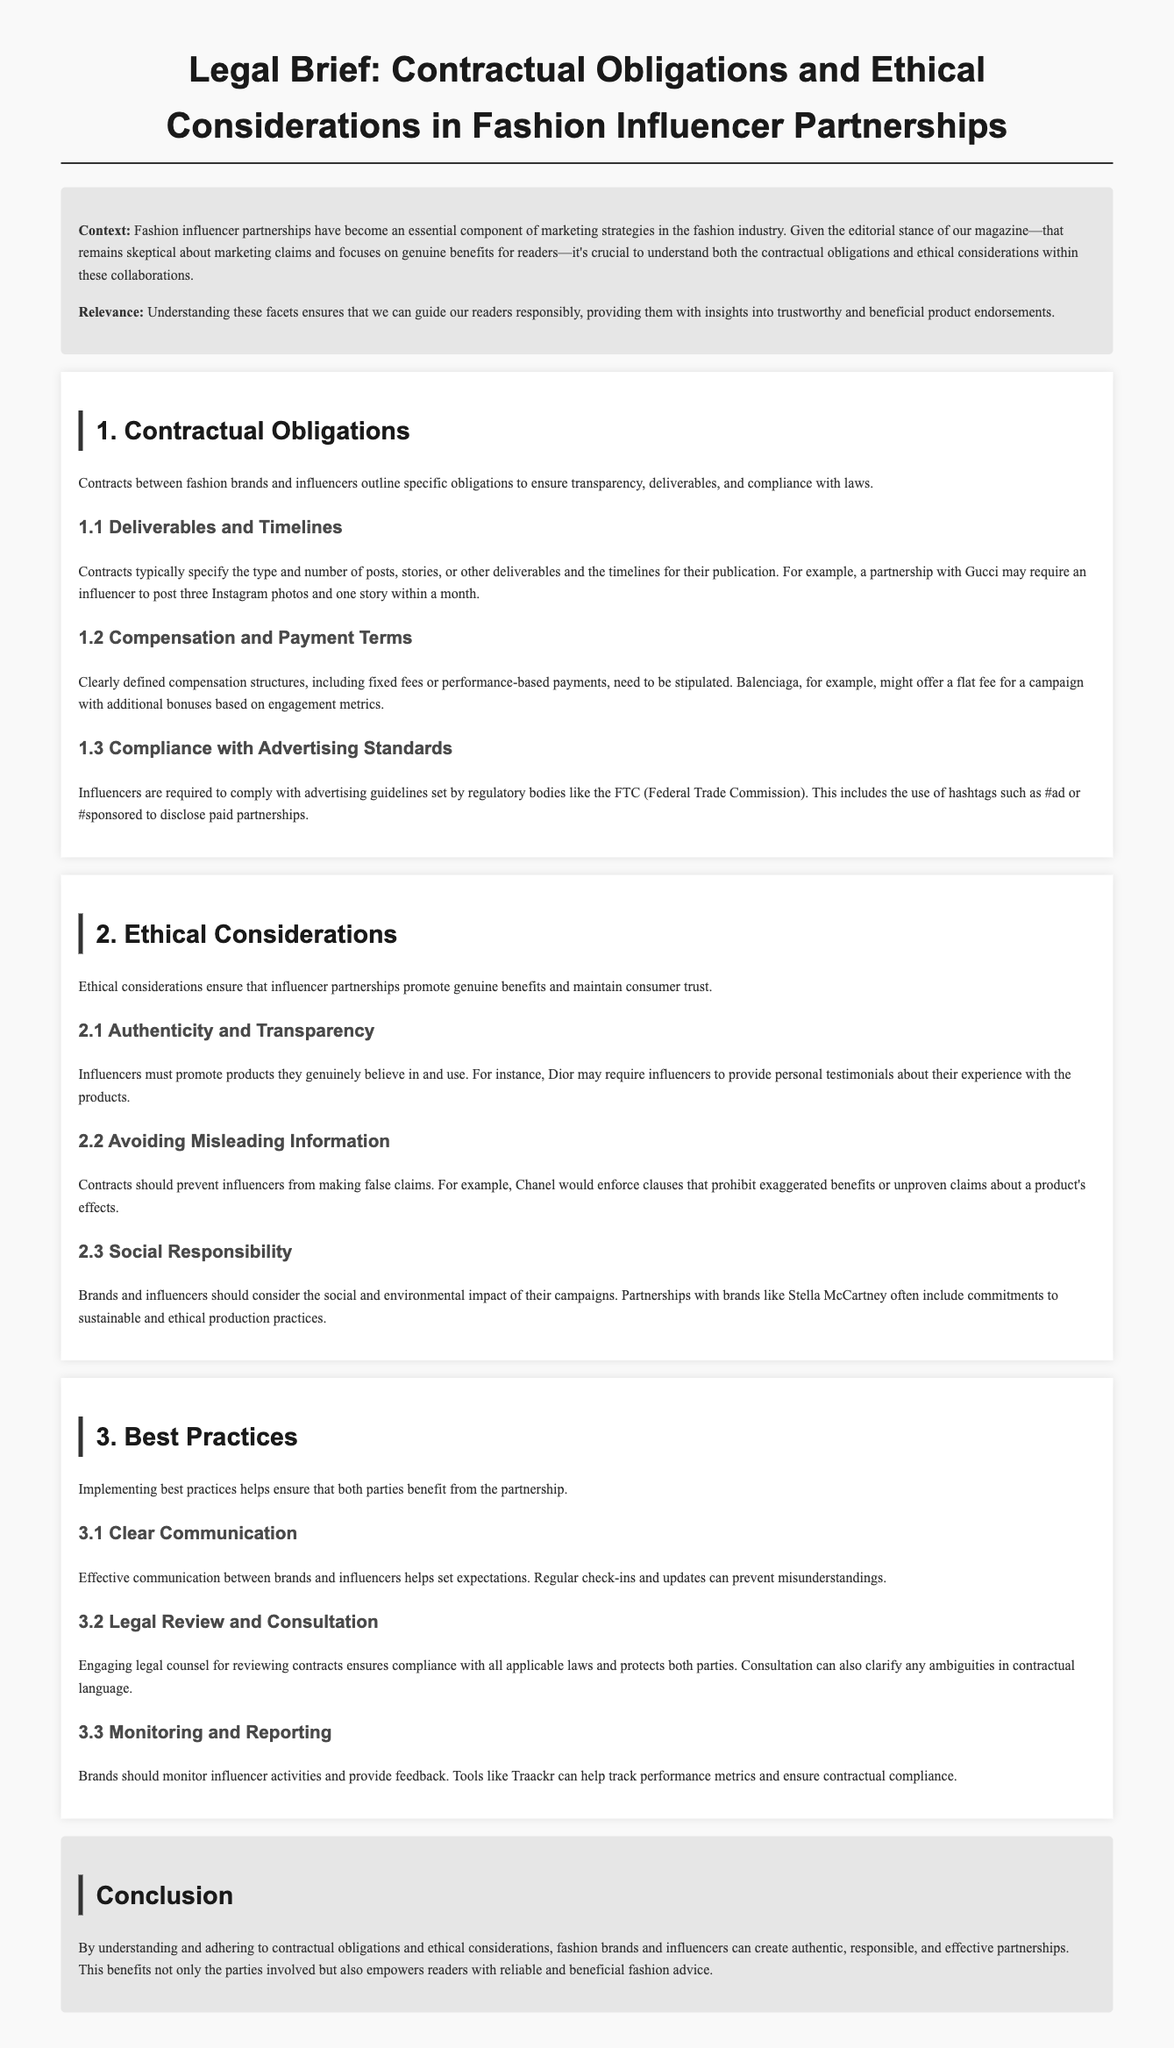what is the primary focus of the legal brief? The primary focus of the legal brief is to understand contractual obligations and ethical considerations in fashion influencer partnerships.
Answer: contractual obligations and ethical considerations who is required to comply with advertising standards? Influencers are required to comply with advertising standards set by regulatory bodies like the FTC.
Answer: Influencers what is one example of a deliverable that may be specified in influencer contracts? An example of a deliverable that may be specified is a certain number of Instagram posts.
Answer: Instagram posts what guidelines should influencers follow when promoting products? Influencers should follow the guidelines set by regulatory bodies like the FTC, using disclosures like #ad.
Answer: FTC guidelines how can brands ensure clear communication with influencers? Brands can ensure clear communication by having regular check-ins and updates.
Answer: regular check-ins why is legal review important for influencer contracts? Legal review is important to ensure compliance with all applicable laws and protect both parties.
Answer: compliance with laws what social aspect is discussed in the ethical considerations section? The social aspect mentioned is social responsibility regarding the impact of campaigns.
Answer: social responsibility what organization might require influencers to avoid exaggerated claims? The organization that might require this is Chanel.
Answer: Chanel how can brands monitor the activities of influencers? Brands can monitor influencer activities using tools like Traackr to track performance metrics.
Answer: Traackr 